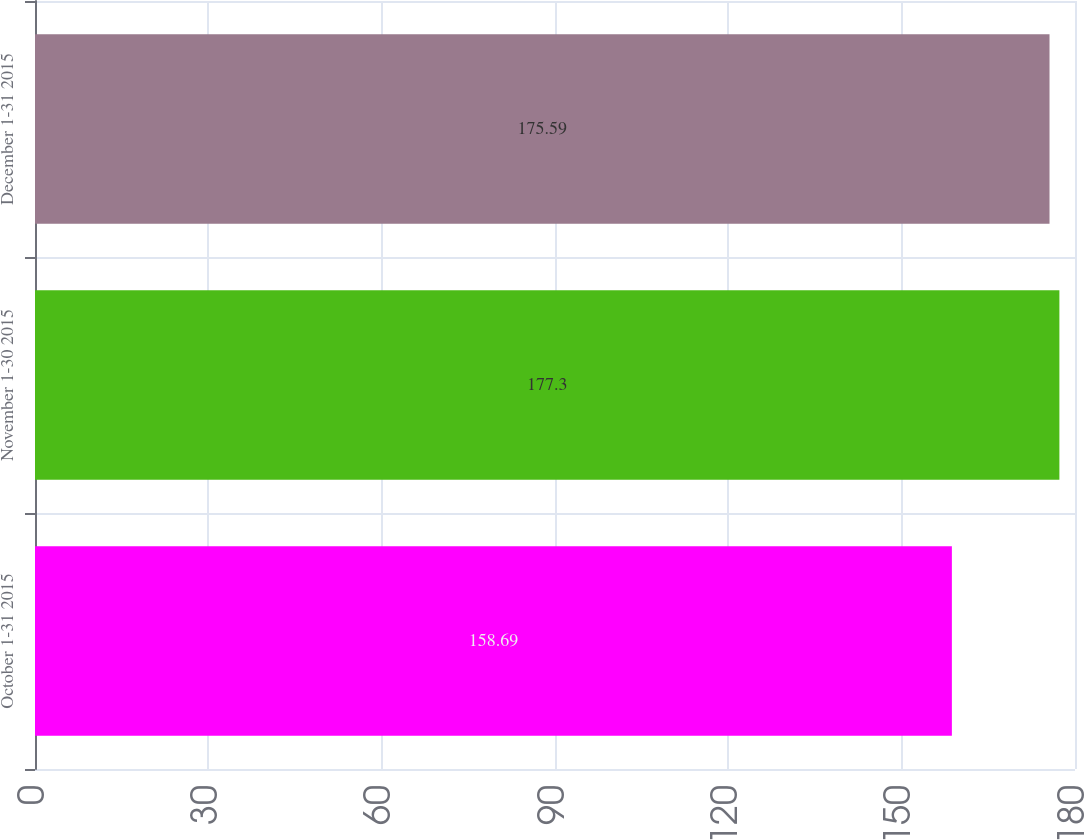<chart> <loc_0><loc_0><loc_500><loc_500><bar_chart><fcel>October 1-31 2015<fcel>November 1-30 2015<fcel>December 1-31 2015<nl><fcel>158.69<fcel>177.3<fcel>175.59<nl></chart> 